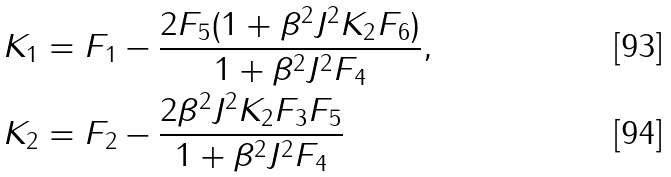<formula> <loc_0><loc_0><loc_500><loc_500>K _ { 1 } & = F _ { 1 } - \frac { 2 F _ { 5 } ( 1 + \beta ^ { 2 } J ^ { 2 } K _ { 2 } F _ { 6 } ) } { 1 + \beta ^ { 2 } J ^ { 2 } F _ { 4 } } , \\ K _ { 2 } & = F _ { 2 } - \frac { 2 \beta ^ { 2 } J ^ { 2 } K _ { 2 } F _ { 3 } F _ { 5 } } { 1 + \beta ^ { 2 } J ^ { 2 } F _ { 4 } }</formula> 